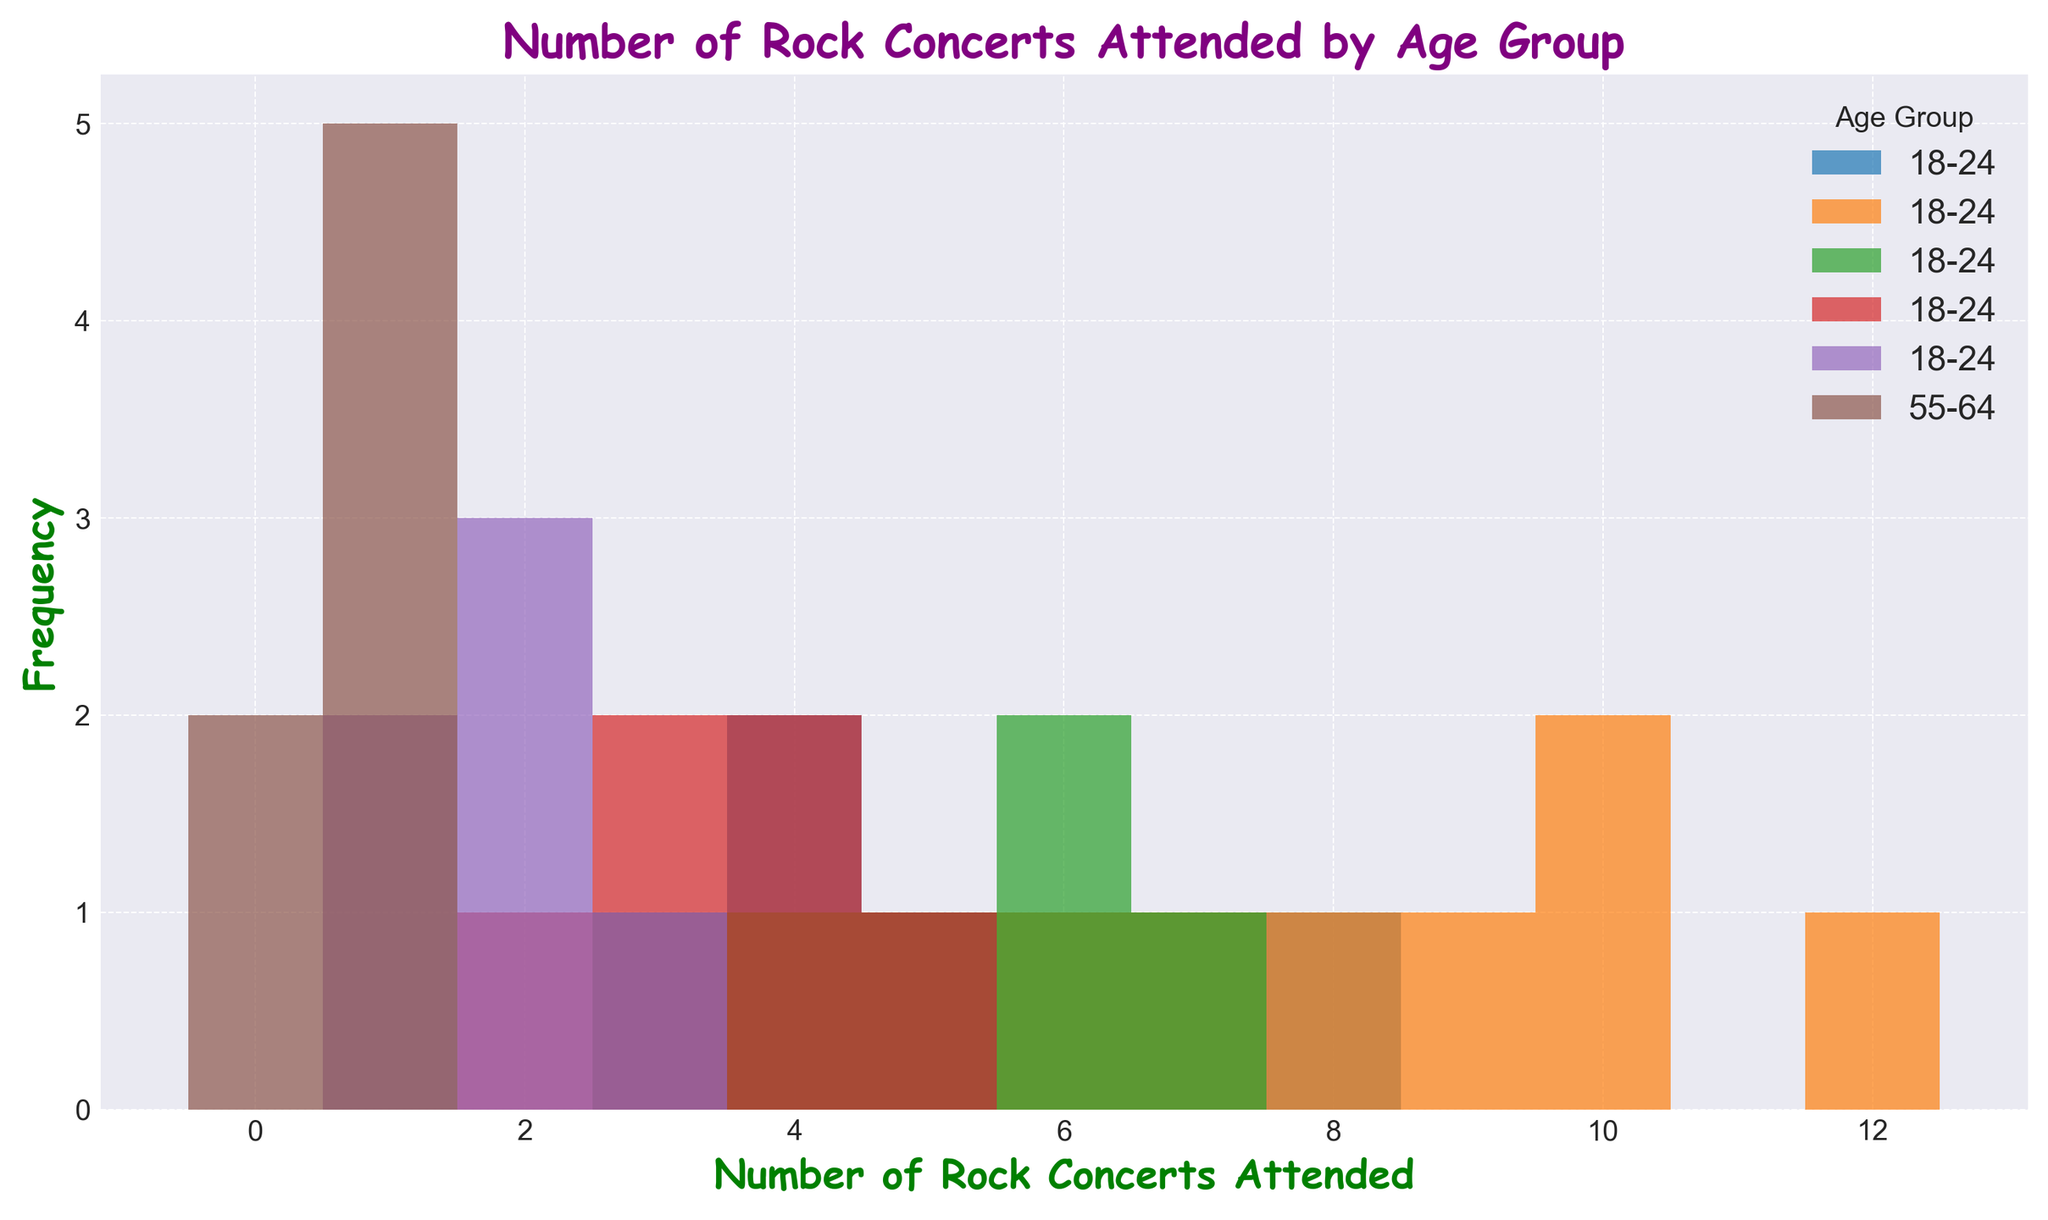Which age group attends the most rock concerts on average? First, identify the number of concerts attended by each age group. Then, calculate each group's average by summing the individual values and dividing by the number of entries. For 18-24: (5+7+3+4+6+8+4)/7 = 5.29; for 25-34: (7+10+8+9+6+12+10)/7 = 8.29; for 35-44: (3+4+6+5+7+6)/6 = 5.17; for 45-54: (2+3+4+5+4+3)/6 = 3.50; for 55-64: (1+2+2+3+1+2)/6 = 1.83; for 65+: (1+1+0+1+0+1+1)/7 = 0.71. The 25-34 age group has the highest average of 8.29.
Answer: 25-34 Which age group has the widest range of rock concerts attended? Calculate the range by subtracting the minimum number of concerts attended from the maximum for each age group: (18-24: 8-3=5), (25-34: 12-6=6), (35-44: 7-3=4), (45-54: 5-2=3), (55-64: 3-1=2), (65+: 1-0=1). The 25-34 age group has the widest range with a range of 6.
Answer: 25-34 How many times does the 18-24 age group attend 4 rock concerts? Look at the histogram's bars for the 18-24 age group and count the height of the bar representing 4 concerts. The bar height for 4 concerts attended is 2.
Answer: 2 Which two age groups have the closest average attendance of rock concerts? Calculate the averages for each age group: (18-24: 5.29), (25-34: 8.29), (35-44: 5.17), (45-54: 3.50), (55-64: 1.83), (65+: 0.71). The closest averages are between age groups 18-24 (5.29) and 35-44 (5.17).
Answer: 18-24 and 35-44 Which age group has the smallest number of individuals attending more than 4 rock concerts? Identify the bars representing more than 4 concerts for each age group and count their frequencies. For 18-24: 5+6+7+8=4; for 25-34: 6+7+8+9+10+12=6; for 35-44: 6+7=2; for 45-54: 5=1; for 55-64: 0; for 65+: 0. The 65+ age group has the smallest number of individuals attending more than 4 concerts, with zero attendees.
Answer: 65+ Which age group's histogram bars are the tallest and what number of rock concerts do they represent? Observe the histogram and identify the age group with the tallest bar, then note the number of concerts this bar represents. The tallest bar is for the 25-34 age group representing 10 concerts attended. The height of this bar is 2.
Answer: 25-34, 10 What is the total number of concerts attended by 45-54 age group across all individuals in that group? Sum the number of concerts attended for all individuals in the 45-54 age group: (2+3+4+5+4+3 = 21). The total number of concerts attended by the 45-54 age group is 21.
Answer: 21 What is the most frequent number of rock concerts attended by the 55-64 age group? Look at the histogram bars for the 55-64 age group and identify the highest bar, which indicates the most frequent number. The highest bar for the 55-64 age group is at 2 concerts attended.
Answer: 2 How many people in the 35-44 age group attended at least 5 rock concerts? Count the bars for the 35-44 age group that equal or exceed 5 concerts attended. There are 2 people who attended 6 concerts and 1 who attended 5, summing up to 3 individuals.
Answer: 3 